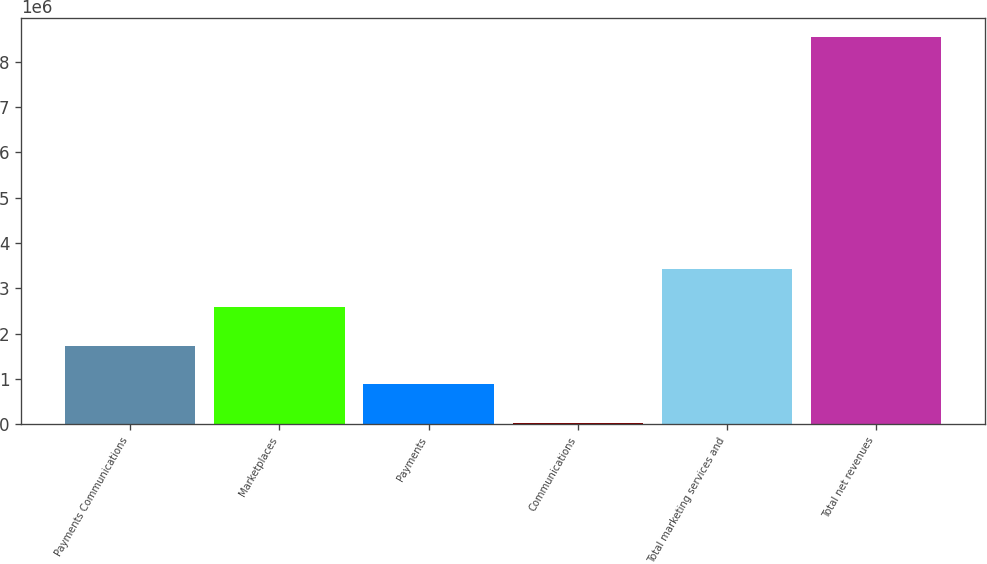Convert chart. <chart><loc_0><loc_0><loc_500><loc_500><bar_chart><fcel>Payments Communications<fcel>Marketplaces<fcel>Payments<fcel>Communications<fcel>Total marketing services and<fcel>Total net revenues<nl><fcel>1.72828e+06<fcel>2.5799e+06<fcel>876660<fcel>25038<fcel>3.43153e+06<fcel>8.54126e+06<nl></chart> 